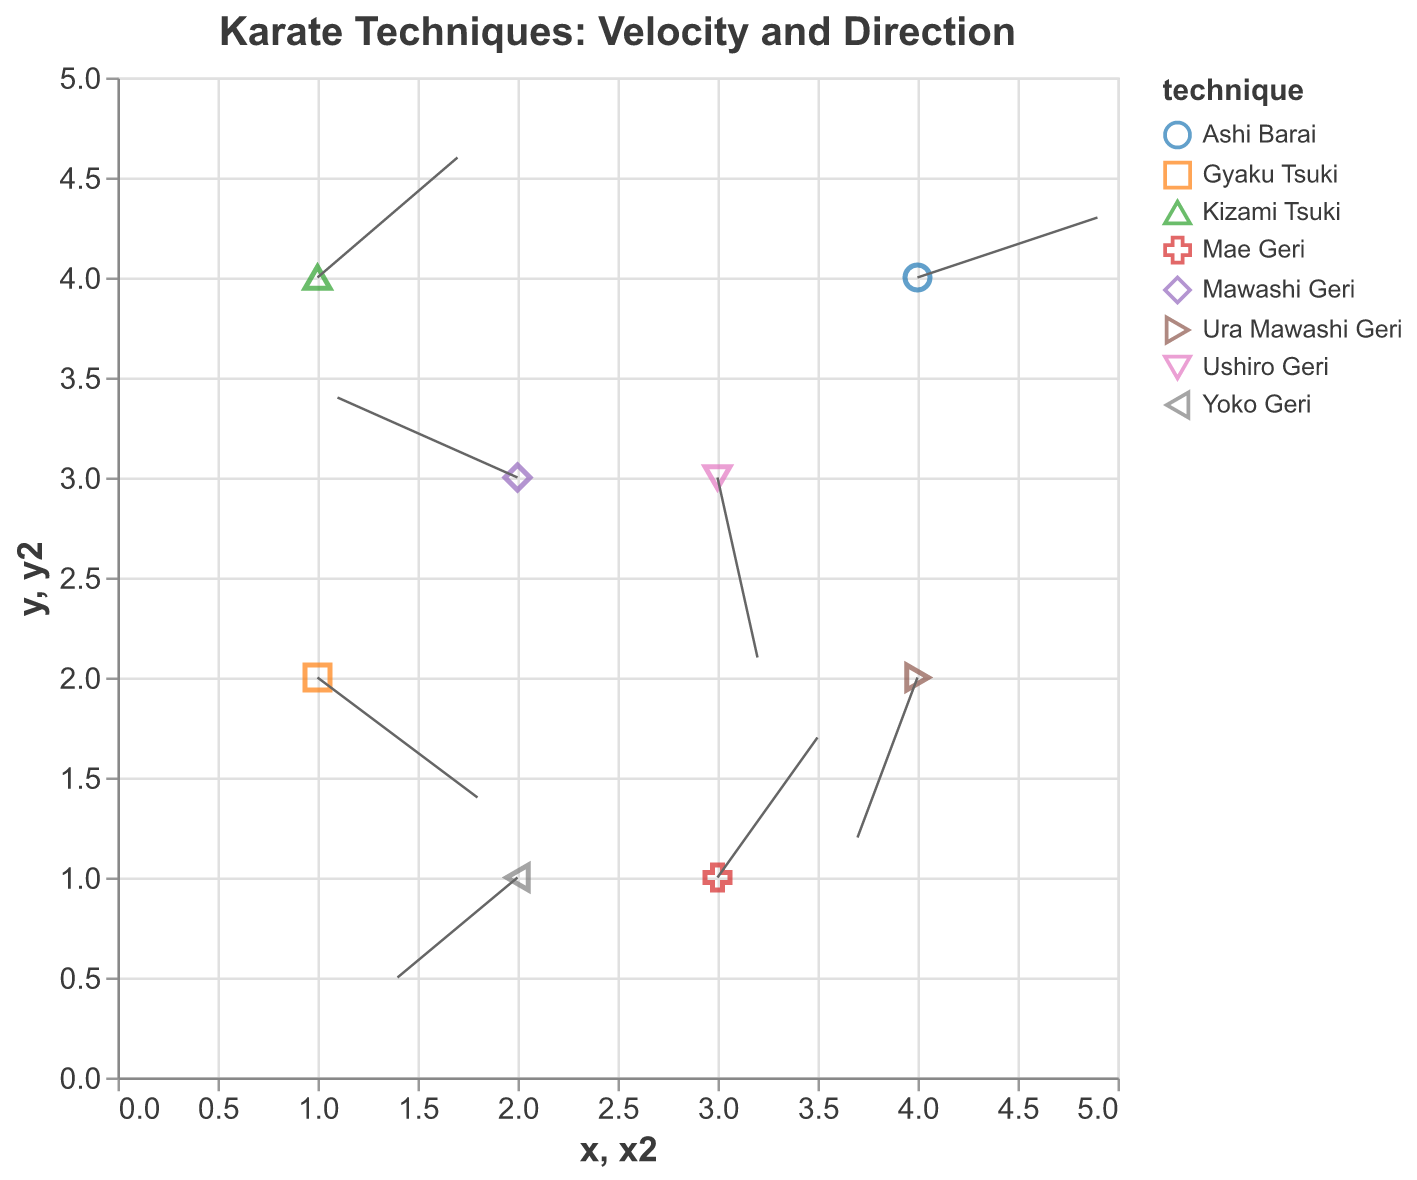What's the title of the figure? The title is provided in the visual information at the top of the figure. It is `"Karate Techniques: Velocity and Direction"`.
Answer: Karate Techniques: Velocity and Direction How many athletes' data points are shown in the figure? Each athlete is represented by a point in the figure. By counting the number of points, we see there are 8 data points.
Answer: 8 Which technique shows the highest positive horizontal (x) component of attack velocity? The horizontal velocity (x component) is given by the 'u' values. The highest positive 'u' value is from 0.9 by Lucas Almeida performing Ashi Barai.
Answer: Ashi Barai What are the velocity components (u and v) of Juliana Costa's attack? Juliana Costa's attack is marked with 'u' and 'v' values in the figure. According to the data, her velocity components are 0.7 (u) and 0.6 (v).
Answer: 0.7, 0.6 Which technique has the strongest downward (negative y) direction? The downward direction is given by the most negative 'v' value. Rafael Mendes' Ushiro Geri has the most negative 'v' of -0.9.
Answer: Ushiro Geri How many techniques have a negative 'u' component? A negative 'u' component indicates a leftward direction. There are three techniques with a negative 'u' component: Mawashi Geri, Ura Mawashi Geri, and Yoko Geri.
Answer: 3 Which athlete has the smallest magnitude of total velocity? The total velocity magnitude can be calculated using the formula √(u² + v²). Calculating for all athletes:
- Maria Silva: √(0.8² + (-0.6)²) = √(0.64 + 0.36) = √1 = 1
- Carlos Oliveira: √(0.5² + 0.7²) = √(0.25 + 0.49) = √0.74 ≈ 0.86
- Ana Santos: √((-0.9)² + 0.4²) = √(0.81 + 0.16) = √0.97 ≈ 0.98
- Pedro Ferreira: √((-0.3)² + (-0.8)²) = √(0.09 + 0.64) = √0.73 ≈ 0.85
- Juliana Costa: √(0.7² + 0.6²) = √(0.49 + 0.36) = √0.85 ≈ 0.92
- Rafael Mendes: √(0.2² + (-0.9)²) = √(0.04 + 0.81) = √0.85 ≈ 0.92
- Fernanda Lima: √((-0.6)² + (-0.5)²) = √(0.36 + 0.25) = √0.61 ≈ 0.78
- Lucas Almeida: √(0.9² + 0.3²) = √(0.81 + 0.09) = √0.9 = 0.95
The smallest magnitude is for Carlos Oliveira.
Answer: Carlos Oliveira Which athlete's attack is closest to the origin (0,0)? The distance to the origin can be calculated using the formula √(x² + y²). Calculating for all athletes:
- Maria Silva: √(1² + 2²) = √5 ≈ 2.24
- Carlos Oliveira: √(3² + 1²) = √10 ≈ 3.16
- Ana Santos: √(2² + 3²) = √13 ≈ 3.61
- Pedro Ferreira: √(4² + 2²) = √20 ≈ 4.47
- Juliana Costa: √(1² + 4²) = √17 ≈ 4.12
- Rafael Mendes: √(3² + 3²) = √18 ≈ 4.24
- Fernanda Lima: √(2² + 1²) = √5 ≈ 2.24
- Lucas Almeida: √(4² + 4²) = √32 ≈ 5.66
The attacks of Maria Silva and Fernanda Lima are equally closest to the origin.
Answer: Maria Silva, Fernanda Lima 